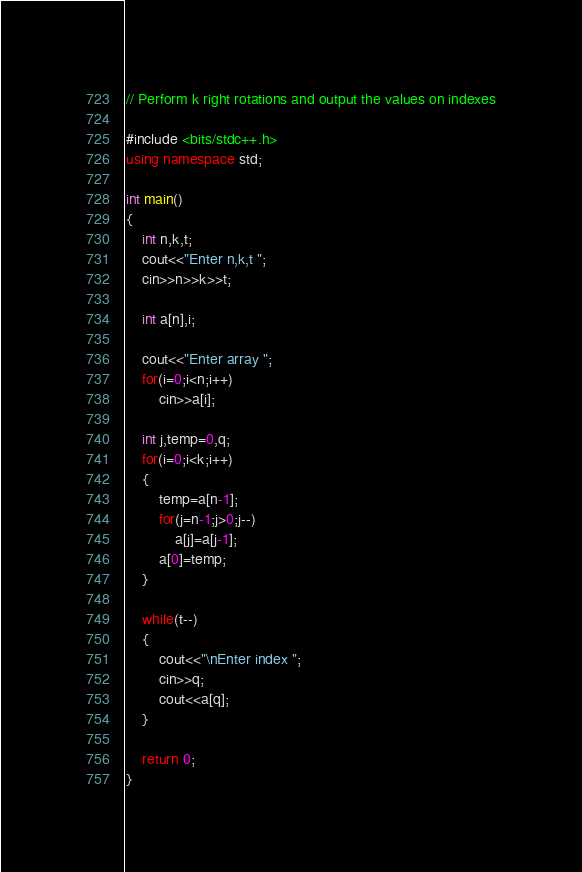Convert code to text. <code><loc_0><loc_0><loc_500><loc_500><_C++_>// Perform k right rotations and output the values on indexes

#include <bits/stdc++.h>
using namespace std;

int main()
{
    int n,k,t;
    cout<<"Enter n,k,t ";
    cin>>n>>k>>t;
    
    int a[n],i;
    
    cout<<"Enter array ";
    for(i=0;i<n;i++)
        cin>>a[i];
        
    int j,temp=0,q;
    for(i=0;i<k;i++)
    {
        temp=a[n-1];
        for(j=n-1;j>0;j--)
            a[j]=a[j-1];
        a[0]=temp;
    }
    
    while(t--)
    {
        cout<<"\nEnter index ";
        cin>>q;
        cout<<a[q];
    }
        
    return 0;
}
</code> 